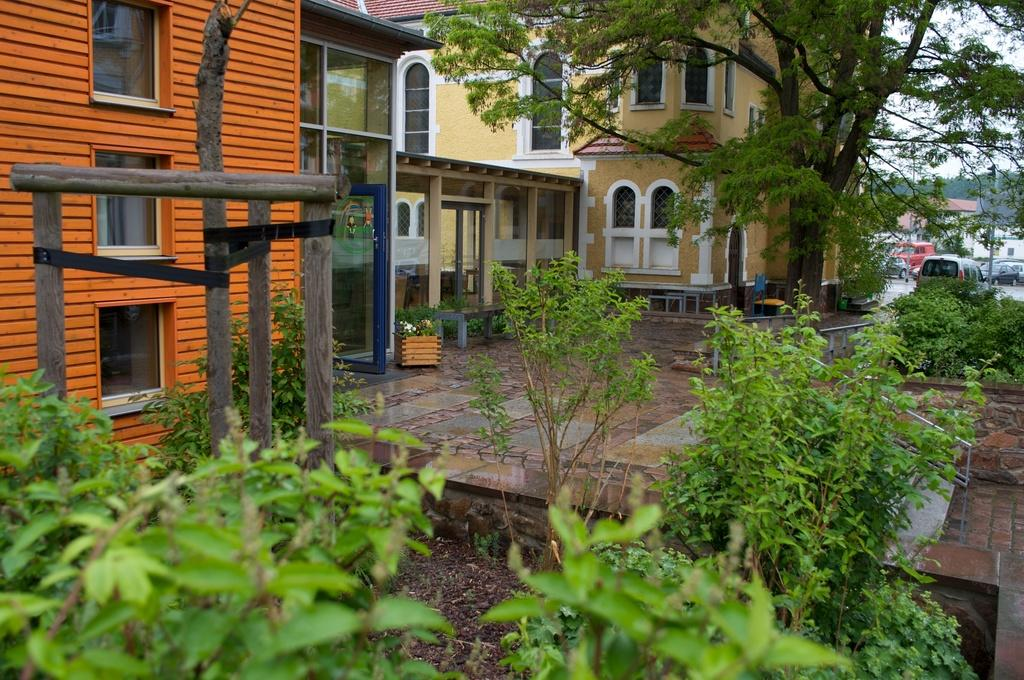What type of natural elements can be seen in the image? There are trees and plants in the image. What type of man-made structures are present in the image? There are buildings and wooden poles in the image. What type of objects are used for transportation in the image? Vehicles are visible in the image. What type of objects are used for seating in the image? There are benches in the image. What is the surface on which the objects are placed in the image? The bottom of the image contains a floor. How many lizards are sitting on the benches in the image? There are no lizards present in the image. What is the time of day in the image? The time of day is not mentioned in the image, so it cannot be determined. 